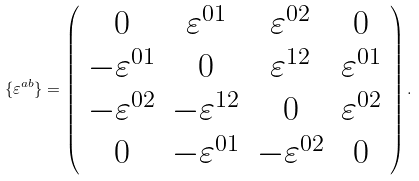<formula> <loc_0><loc_0><loc_500><loc_500>\{ \varepsilon ^ { a b } \} = \left ( \begin{array} { c c c c } 0 & \varepsilon ^ { 0 1 } & \varepsilon ^ { 0 2 } & 0 \\ - \varepsilon ^ { 0 1 } & 0 & \varepsilon ^ { 1 2 } & \varepsilon ^ { 0 1 } \\ - \varepsilon ^ { 0 2 } & - \varepsilon ^ { 1 2 } & 0 & \varepsilon ^ { 0 2 } \\ 0 & - \varepsilon ^ { 0 1 } & - \varepsilon ^ { 0 2 } & 0 \end{array} \right ) .</formula> 